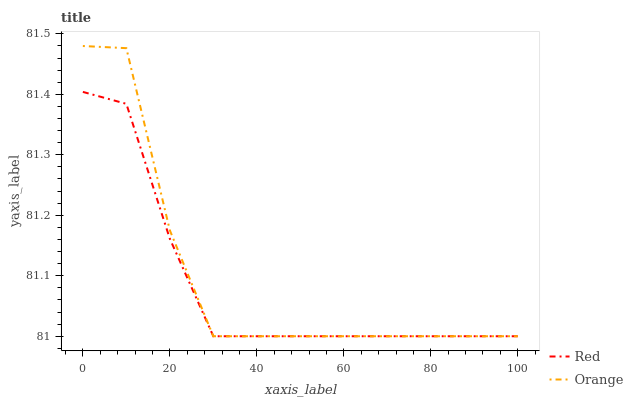Does Red have the minimum area under the curve?
Answer yes or no. Yes. Does Orange have the maximum area under the curve?
Answer yes or no. Yes. Does Red have the maximum area under the curve?
Answer yes or no. No. Is Red the smoothest?
Answer yes or no. Yes. Is Orange the roughest?
Answer yes or no. Yes. Is Red the roughest?
Answer yes or no. No. Does Orange have the lowest value?
Answer yes or no. Yes. Does Orange have the highest value?
Answer yes or no. Yes. Does Red have the highest value?
Answer yes or no. No. Does Orange intersect Red?
Answer yes or no. Yes. Is Orange less than Red?
Answer yes or no. No. Is Orange greater than Red?
Answer yes or no. No. 